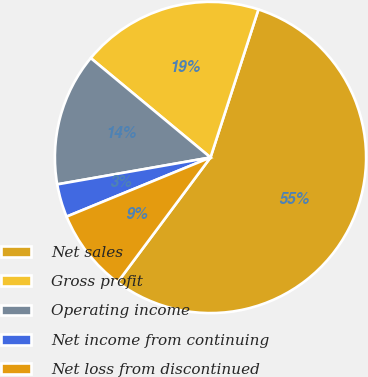Convert chart. <chart><loc_0><loc_0><loc_500><loc_500><pie_chart><fcel>Net sales<fcel>Gross profit<fcel>Operating income<fcel>Net income from continuing<fcel>Net loss from discontinued<nl><fcel>55.2%<fcel>18.96%<fcel>13.79%<fcel>3.44%<fcel>8.61%<nl></chart> 